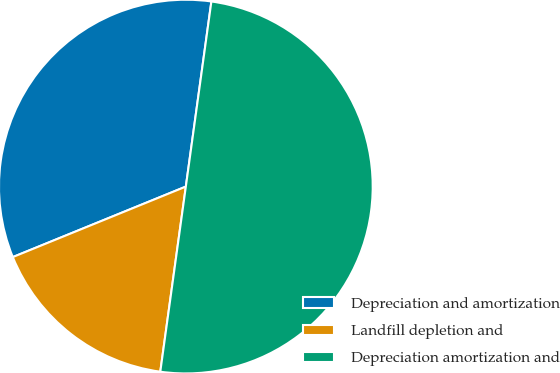<chart> <loc_0><loc_0><loc_500><loc_500><pie_chart><fcel>Depreciation and amortization<fcel>Landfill depletion and<fcel>Depreciation amortization and<nl><fcel>33.34%<fcel>16.66%<fcel>50.0%<nl></chart> 